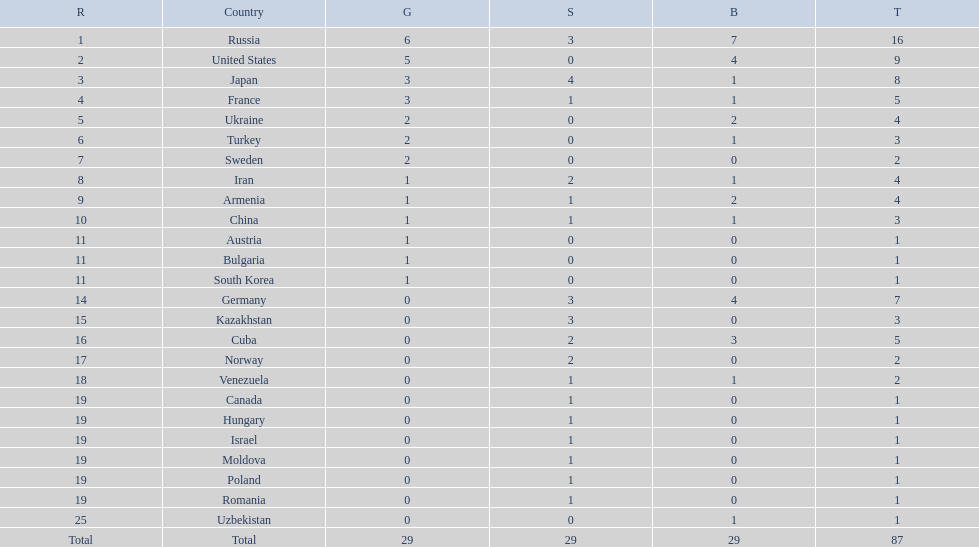Where did iran rank? 8. Where did germany rank? 14. Which of those did make it into the top 10 rank? Germany. 